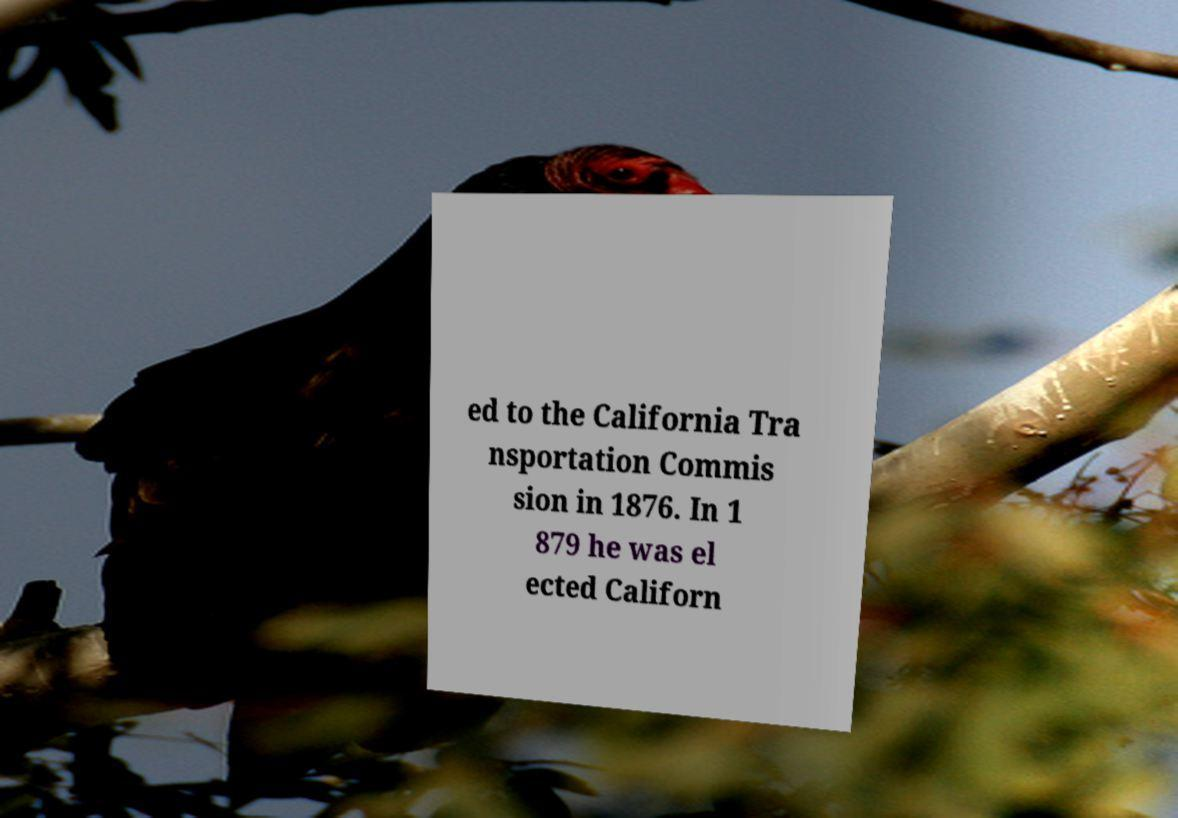Can you accurately transcribe the text from the provided image for me? ed to the California Tra nsportation Commis sion in 1876. In 1 879 he was el ected Californ 